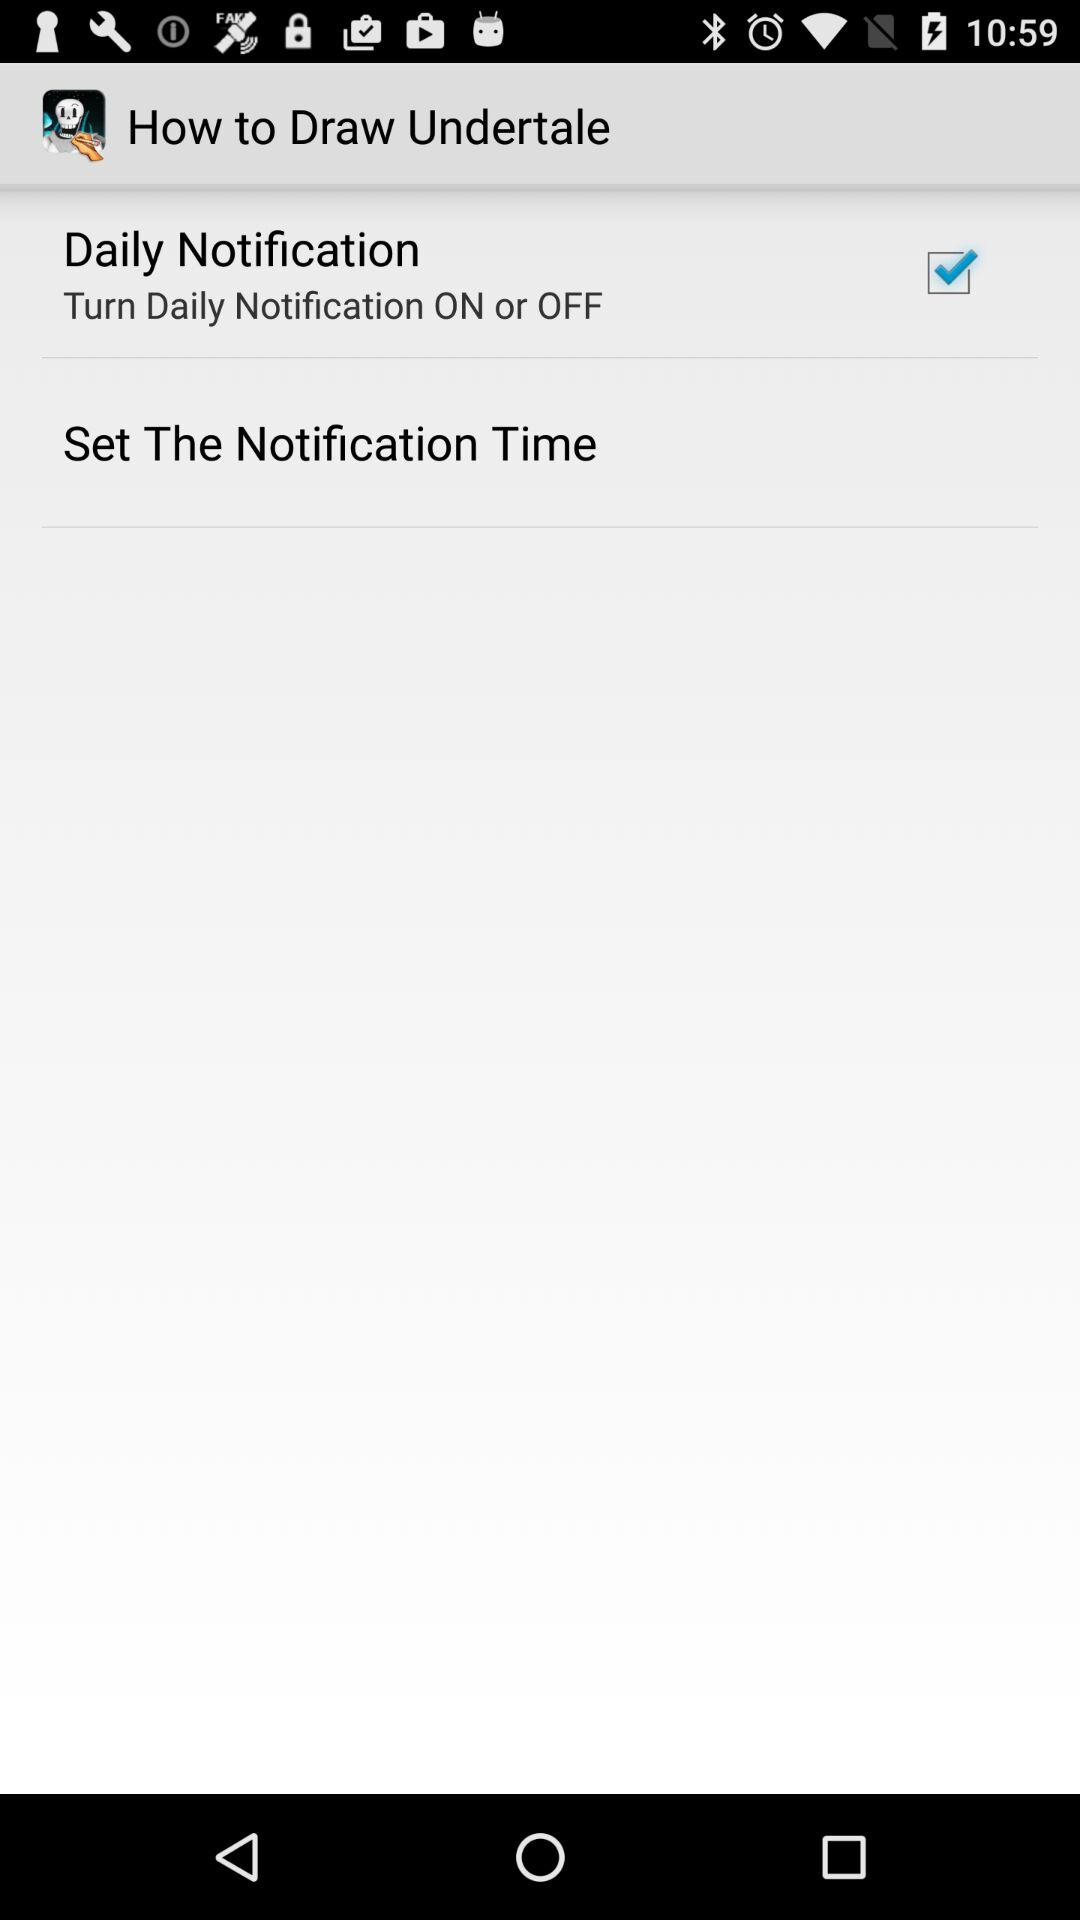What is the status of "Daily Notification"? The status of "Daily Notification" is "on". 